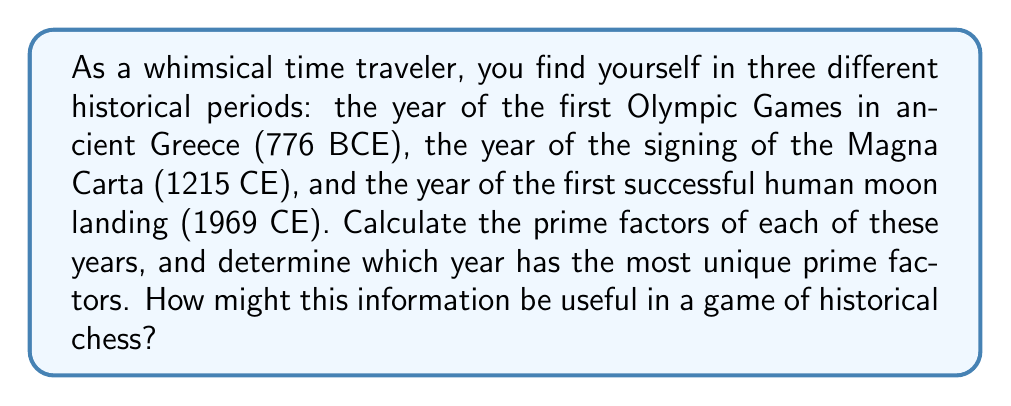Help me with this question. Let's break this down step-by-step:

1) First, we need to convert 776 BCE to a positive number for factorization. We'll use 776.

2) Now, let's find the prime factors of each year:

   For 776:
   $776 = 2^3 \times 97$

   For 1215:
   $1215 = 3^5 \times 5$

   For 1969:
   $1969 = 11 \times 179$

3) Counting the unique prime factors:
   776 has 2 unique prime factors (2 and 97)
   1215 has 2 unique prime factors (3 and 5)
   1969 has 2 unique prime factors (11 and 179)

4) All three years have the same number of unique prime factors (2).

5) In terms of a historical chess game, we could use this information to create a unique rule set. For example:
   - Pieces could move according to the number of prime factors (in this case, all would move 2 spaces).
   - The magnitude of the largest prime factor could determine the strength of a piece (1969 would have the strongest pieces, followed by 776, then 1215).
   - The smallest prime factor could determine turn order (776 would go first, then 1215, then 1969).

This creates a whimsical connection between the historical periods and the game of chess, fitting for an art-loving time traveler.
Answer: All three years (776, 1215, and 1969) have 2 unique prime factors each. The prime factorizations are:

$776 = 2^3 \times 97$
$1215 = 3^5 \times 5$
$1969 = 11 \times 179$ 